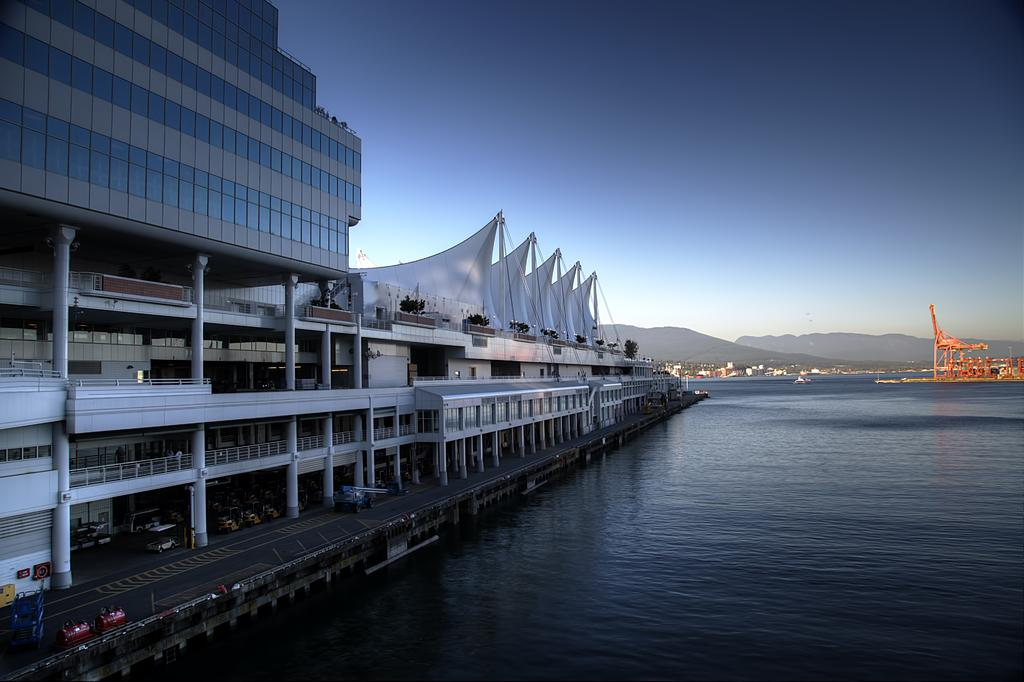What type of structures can be seen in the image? There are buildings in the image. What natural element is visible in the image? There is water visible in the image. What type of vegetation can be seen in the background of the image? There are trees in the background of the image. What is visible at the top of the image? The sky is visible at the top of the image. Can you tell me how many insects are guiding the boats in the image? There are no insects or boats present in the image, so it is not possible to answer that question. 